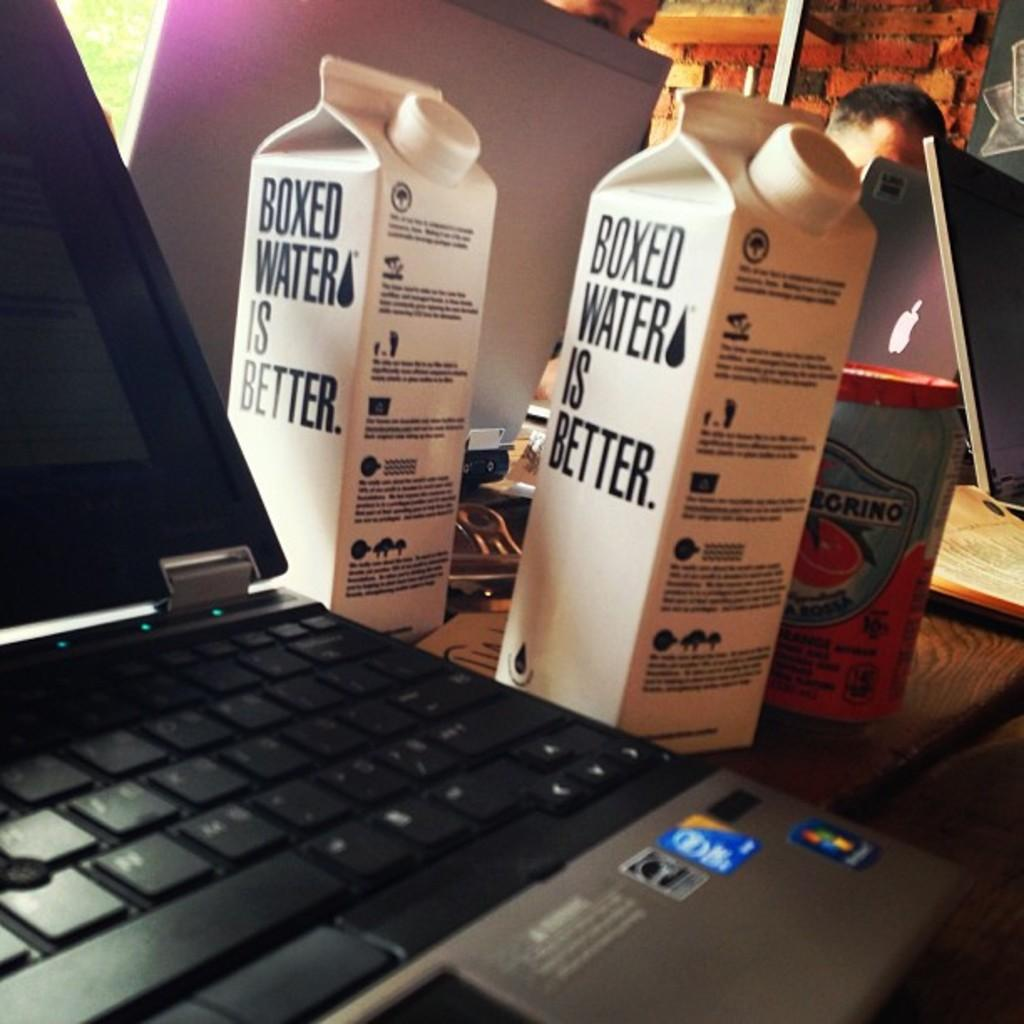<image>
Present a compact description of the photo's key features. 2 cartons that say boxed water is better 